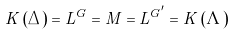Convert formula to latex. <formula><loc_0><loc_0><loc_500><loc_500>K \left ( \Delta \right ) = L ^ { G } = M = L ^ { G ^ { \prime } } = K \left ( \Lambda \right )</formula> 